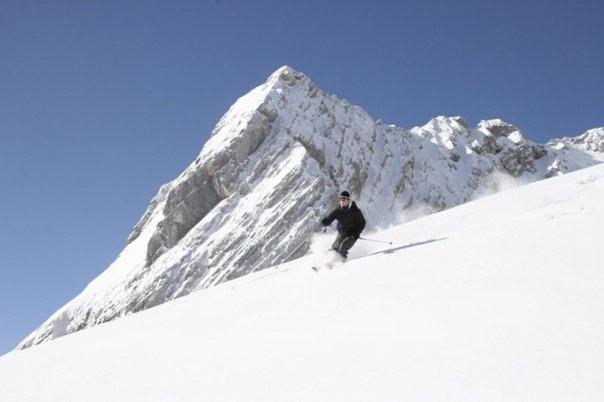What mountain is this?
Short answer required. Everest. Are there any snowboarders?
Answer briefly. No. Where was this picture taken from?
Short answer required. Mountain. What is behind the person?
Concise answer only. Mountain. Is it cold outside?
Give a very brief answer. Yes. Is he going down the hill?
Write a very short answer. Yes. 